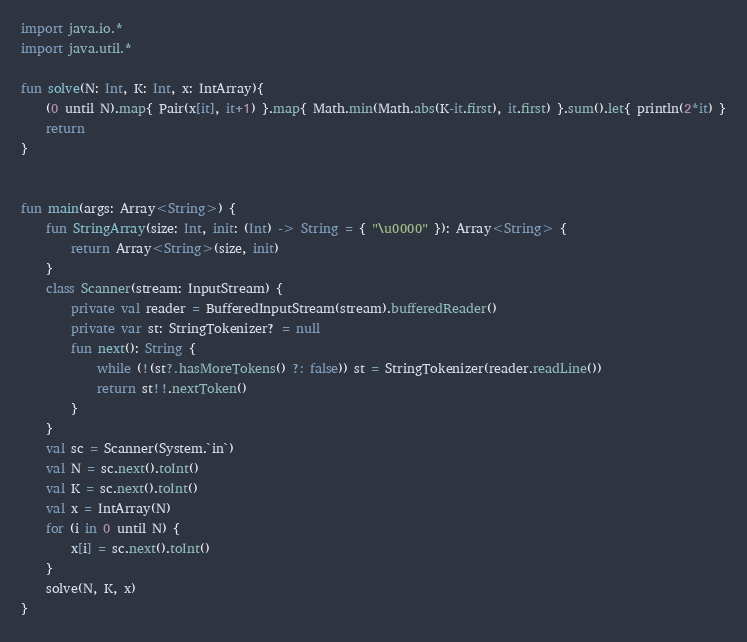<code> <loc_0><loc_0><loc_500><loc_500><_Kotlin_>import java.io.*
import java.util.*

fun solve(N: Int, K: Int, x: IntArray){
    (0 until N).map{ Pair(x[it], it+1) }.map{ Math.min(Math.abs(K-it.first), it.first) }.sum().let{ println(2*it) }
    return
}


fun main(args: Array<String>) {
    fun StringArray(size: Int, init: (Int) -> String = { "\u0000" }): Array<String> {
        return Array<String>(size, init)
    }
    class Scanner(stream: InputStream) {
        private val reader = BufferedInputStream(stream).bufferedReader()
        private var st: StringTokenizer? = null
        fun next(): String {
            while (!(st?.hasMoreTokens() ?: false)) st = StringTokenizer(reader.readLine())
            return st!!.nextToken()
        }
    }
    val sc = Scanner(System.`in`)
    val N = sc.next().toInt()
    val K = sc.next().toInt()
    val x = IntArray(N)
    for (i in 0 until N) {
        x[i] = sc.next().toInt()
    }
    solve(N, K, x)
}

</code> 